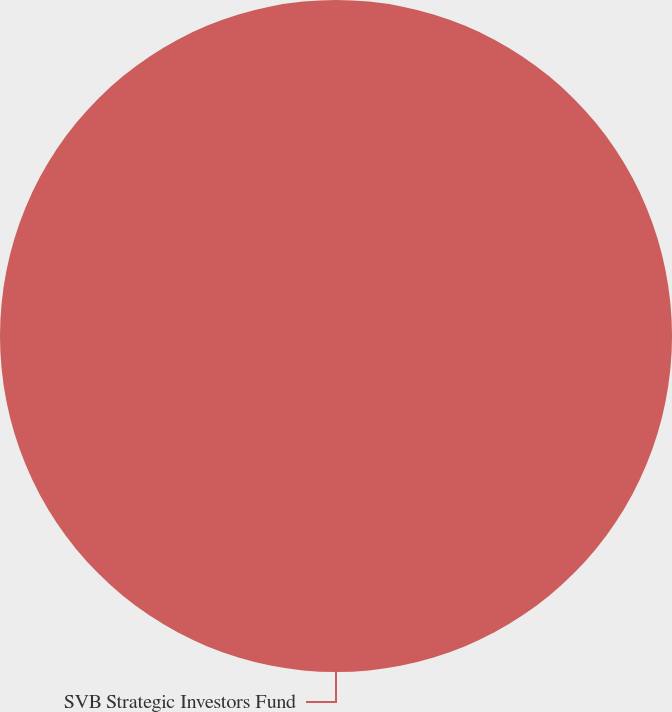Convert chart. <chart><loc_0><loc_0><loc_500><loc_500><pie_chart><fcel>SVB Strategic Investors Fund<nl><fcel>100.0%<nl></chart> 